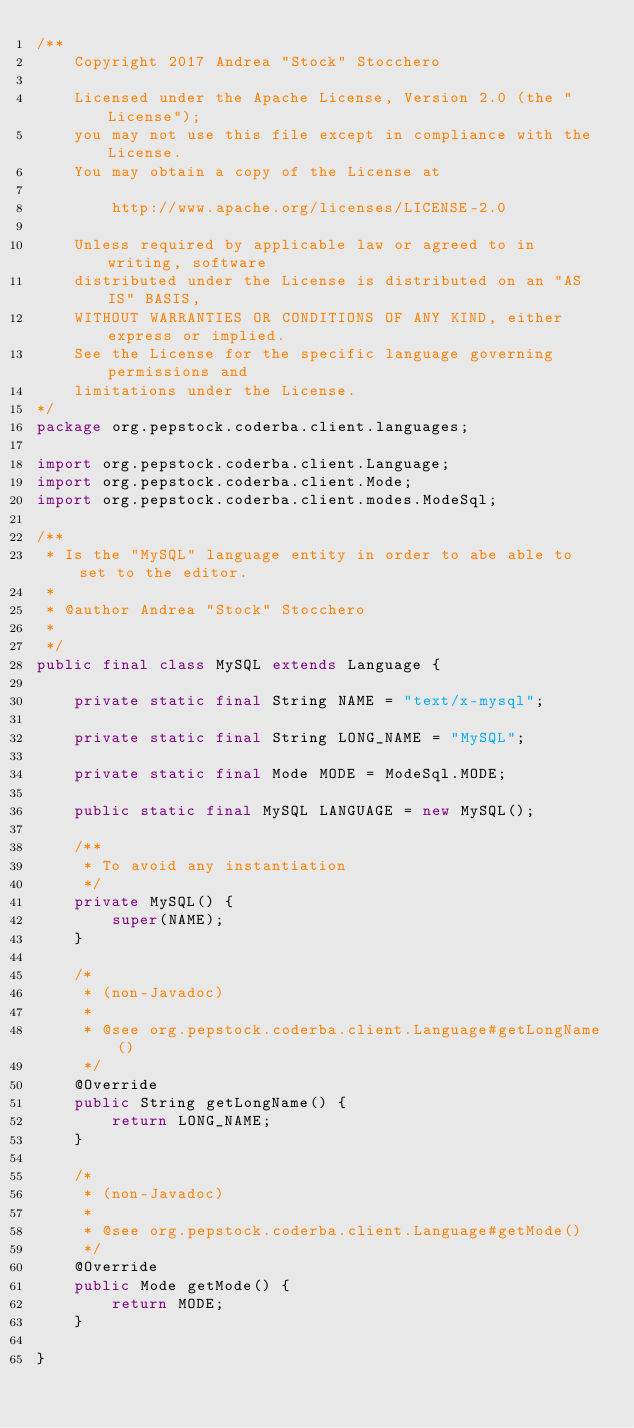Convert code to text. <code><loc_0><loc_0><loc_500><loc_500><_Java_>/**
    Copyright 2017 Andrea "Stock" Stocchero

    Licensed under the Apache License, Version 2.0 (the "License");
    you may not use this file except in compliance with the License.
    You may obtain a copy of the License at

	    http://www.apache.org/licenses/LICENSE-2.0

    Unless required by applicable law or agreed to in writing, software
    distributed under the License is distributed on an "AS IS" BASIS,
    WITHOUT WARRANTIES OR CONDITIONS OF ANY KIND, either express or implied.
    See the License for the specific language governing permissions and
    limitations under the License.
*/
package org.pepstock.coderba.client.languages;

import org.pepstock.coderba.client.Language;
import org.pepstock.coderba.client.Mode;
import org.pepstock.coderba.client.modes.ModeSql;

/**
 * Is the "MySQL" language entity in order to abe able to set to the editor.
 * 
 * @author Andrea "Stock" Stocchero
 *
 */
public final class MySQL extends Language {

	private static final String NAME = "text/x-mysql";

	private static final String LONG_NAME = "MySQL";

	private static final Mode MODE = ModeSql.MODE;

	public static final MySQL LANGUAGE = new MySQL();

	/**
	 * To avoid any instantiation
	 */
	private MySQL() {
		super(NAME);
	}

	/*
	 * (non-Javadoc)
	 * 
	 * @see org.pepstock.coderba.client.Language#getLongName()
	 */
	@Override
	public String getLongName() {
		return LONG_NAME;
	}

	/*
	 * (non-Javadoc)
	 * 
	 * @see org.pepstock.coderba.client.Language#getMode()
	 */
	@Override
	public Mode getMode() {
		return MODE;
	}

}
</code> 